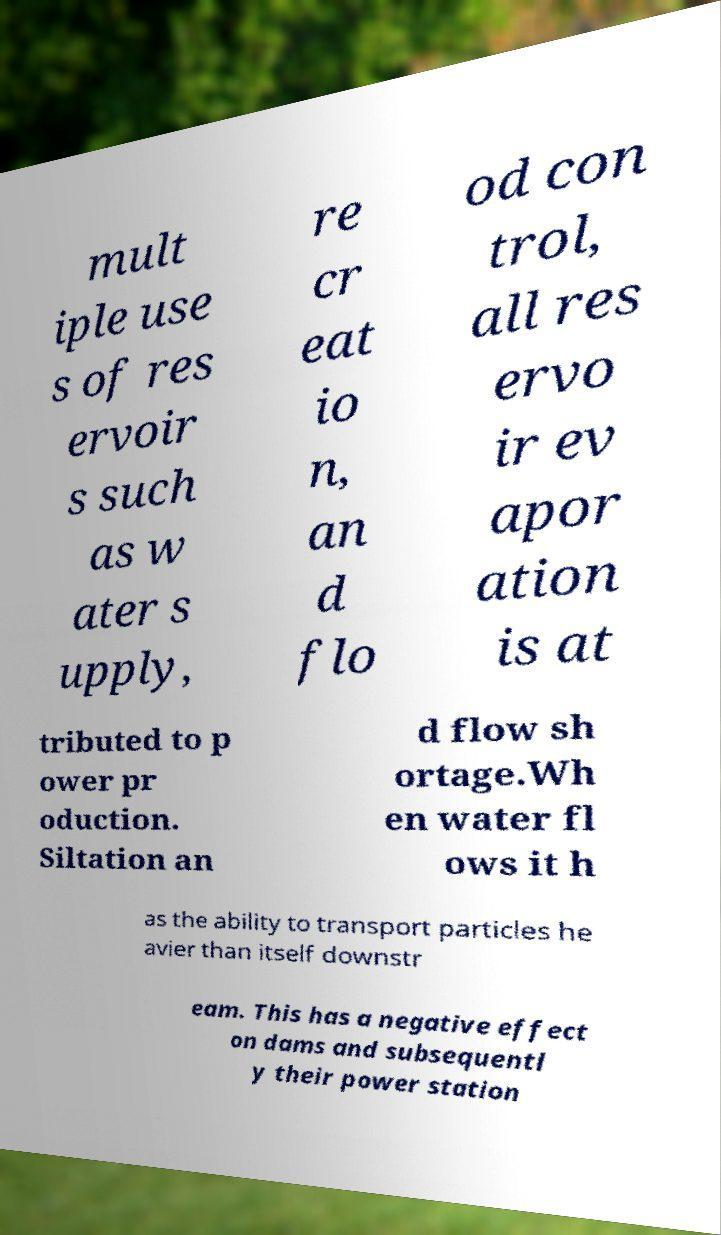There's text embedded in this image that I need extracted. Can you transcribe it verbatim? mult iple use s of res ervoir s such as w ater s upply, re cr eat io n, an d flo od con trol, all res ervo ir ev apor ation is at tributed to p ower pr oduction. Siltation an d flow sh ortage.Wh en water fl ows it h as the ability to transport particles he avier than itself downstr eam. This has a negative effect on dams and subsequentl y their power station 